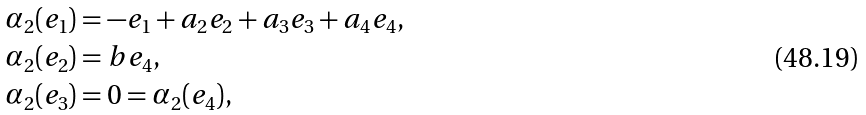<formula> <loc_0><loc_0><loc_500><loc_500>\alpha _ { 2 } ( e _ { 1 } ) & = - e _ { 1 } + a _ { 2 } e _ { 2 } + a _ { 3 } e _ { 3 } + a _ { 4 } e _ { 4 } , \\ \alpha _ { 2 } ( e _ { 2 } ) & = b e _ { 4 } , \\ \alpha _ { 2 } ( e _ { 3 } ) & = 0 = \alpha _ { 2 } ( e _ { 4 } ) ,</formula> 